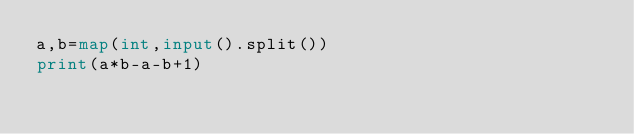Convert code to text. <code><loc_0><loc_0><loc_500><loc_500><_Python_>a,b=map(int,input().split())
print(a*b-a-b+1)</code> 